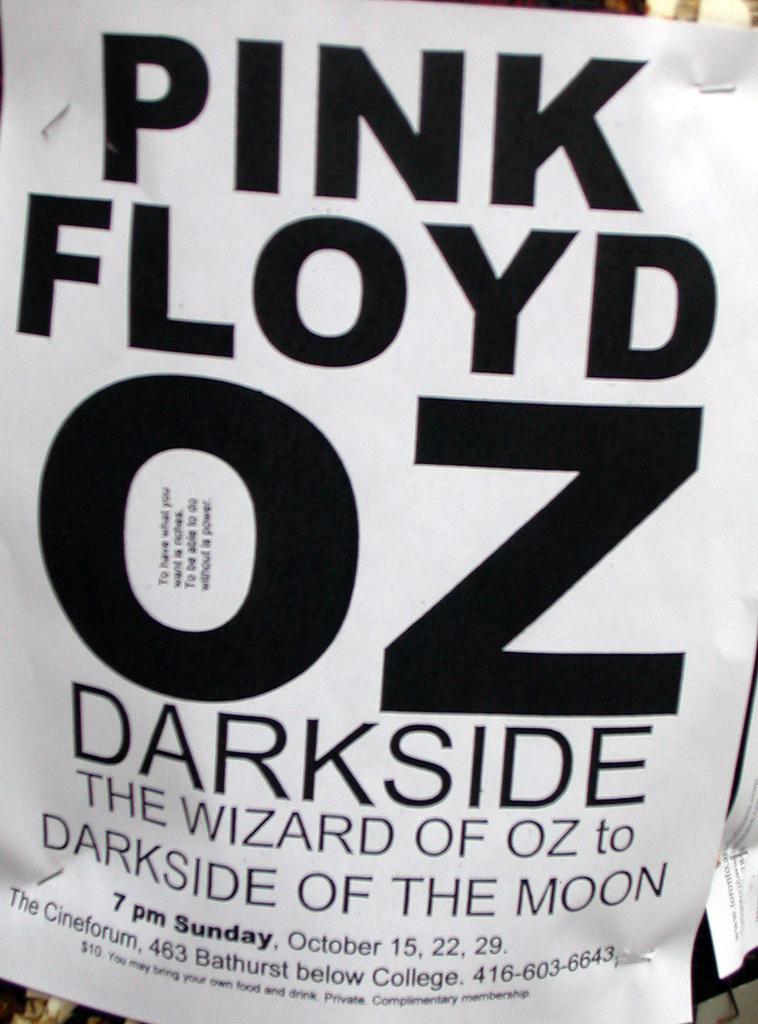Please provide a concise description of this image. In the middle of the image we can see a poster. In the poster we can see some alphabets and numbers. 